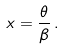<formula> <loc_0><loc_0><loc_500><loc_500>x = \frac { \theta } { \beta } \, .</formula> 